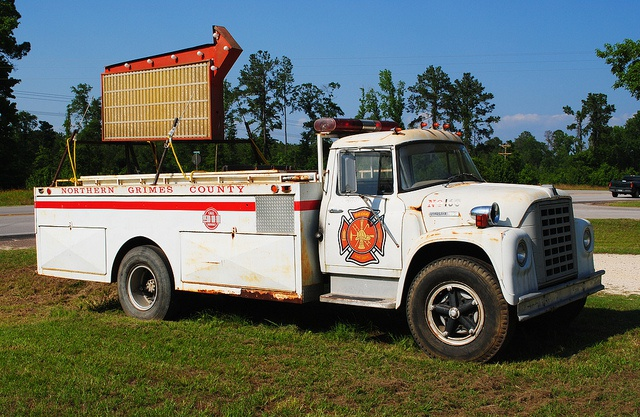Describe the objects in this image and their specific colors. I can see truck in black, lightgray, gray, and darkgray tones and car in black, gray, maroon, and purple tones in this image. 